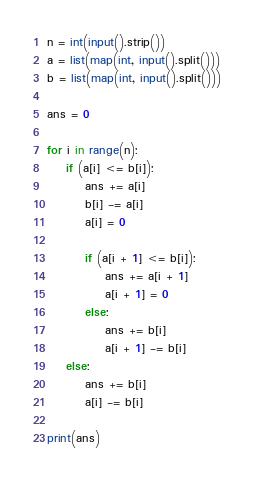<code> <loc_0><loc_0><loc_500><loc_500><_Python_>n = int(input().strip())
a = list(map(int, input().split()))
b = list(map(int, input().split()))

ans = 0

for i in range(n):
    if (a[i] <= b[i]):
        ans += a[i]
        b[i] -= a[i]
        a[i] = 0

        if (a[i + 1] <= b[i]):
            ans += a[i + 1]
            a[i + 1] = 0
        else:
            ans += b[i]
            a[i + 1] -= b[i]
    else:
        ans += b[i]
        a[i] -= b[i]

print(ans)
</code> 